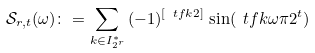Convert formula to latex. <formula><loc_0><loc_0><loc_500><loc_500>\mathcal { S } _ { r , t } ( \omega ) \colon = \sum _ { k \in I _ { 2 ^ { r } } ^ { * } } \, ( - 1 ) ^ { [ \ t f k 2 ] } \, \sin ( \ t f { k \omega \pi } { 2 ^ { t } } )</formula> 